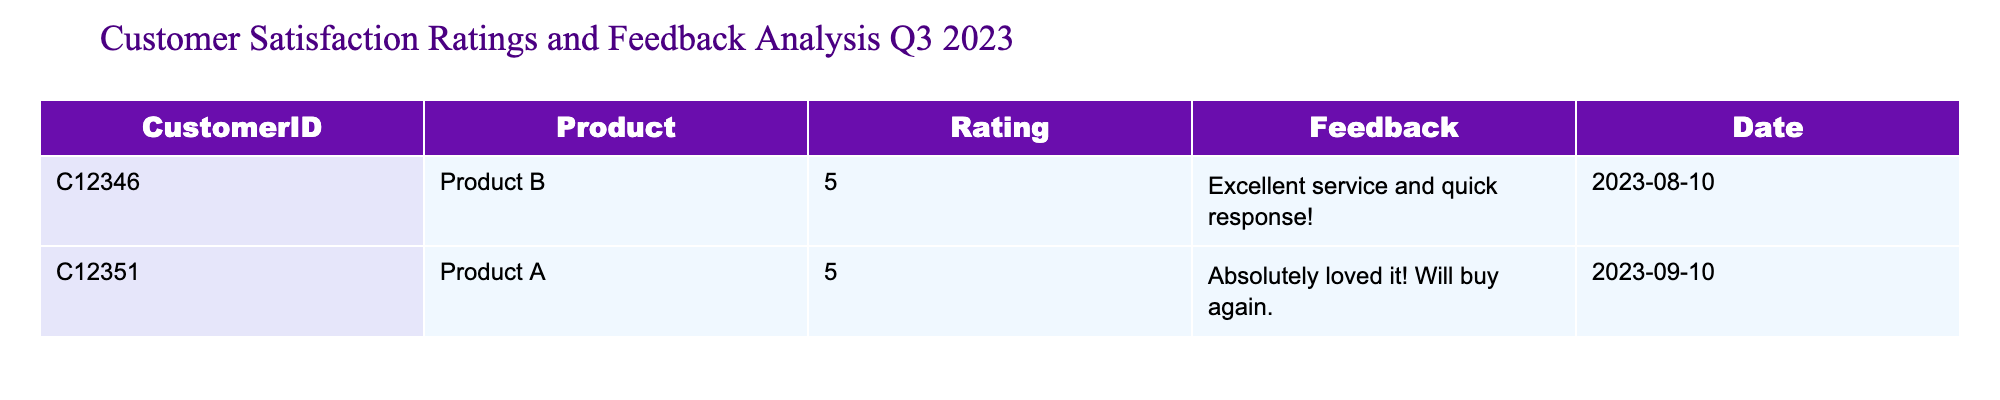What is the rating given by Customer C12346? By looking at the table, we can find the entry for Customer C12346. The rating column indicates a rating of 5 for this customer.
Answer: 5 How many customers provided feedback for Product A? The table shows the entries for each customer, and we can locate Product A in the product column. Only one entry corresponds to Product A, indicating one customer provided feedback.
Answer: 1 What is the average rating from all customers? To calculate the average rating, sum the ratings: 5 (from Customer C12346) + 5 (from Customer C12351) = 10. Since there are 2 customers, the average rating is 10 divided by 2, which equals 5.
Answer: 5 Did any customer give a rating of less than 5? We check the ratings in the table, which show both customers rated their products a 5. Thus, no customer rated less than 5.
Answer: No What feedback did Customer C12351 provide? For Customer C12351, we look up the feedback column in their entry, which states "Absolutely loved it! Will buy again."
Answer: Absolutely loved it! Will buy again Which product received more than one feedback? The table shows only one feedback entry for each product. Thus, neither product received more than one feedback based on the data presented.
Answer: No What is the total sum of ratings for all customers? We add the ratings together: 5 (Customer C12346) + 5 (Customer C12351) = 10. Thus, the total sum of ratings is 10.
Answer: 10 Identify the date when Customer C12346 provided their feedback. From the table, we can directly locate C12346 and see that they provided feedback on 2023-08-10.
Answer: 2023-08-10 How many products were rated by customers in total? The table shows that there are two unique entries, each related to a different product, indicating a total of two products were rated.
Answer: 2 